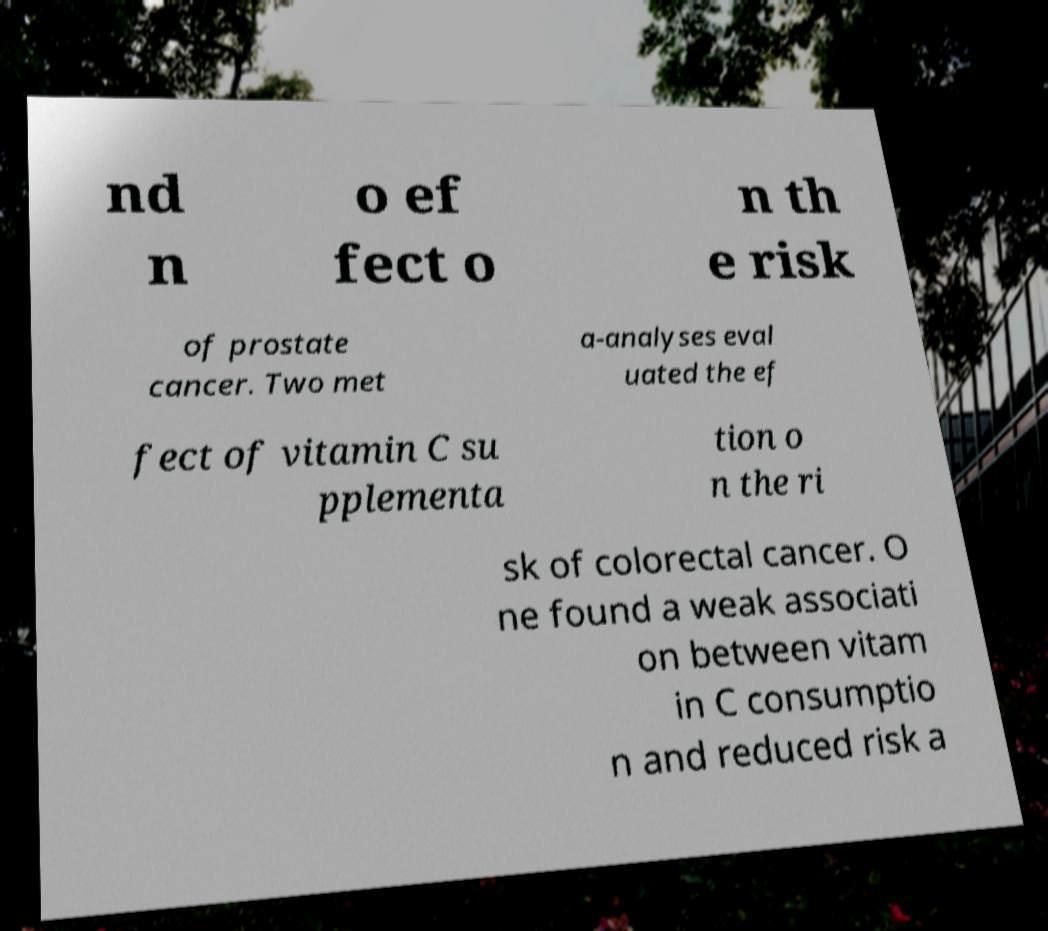Can you read and provide the text displayed in the image?This photo seems to have some interesting text. Can you extract and type it out for me? nd n o ef fect o n th e risk of prostate cancer. Two met a-analyses eval uated the ef fect of vitamin C su pplementa tion o n the ri sk of colorectal cancer. O ne found a weak associati on between vitam in C consumptio n and reduced risk a 